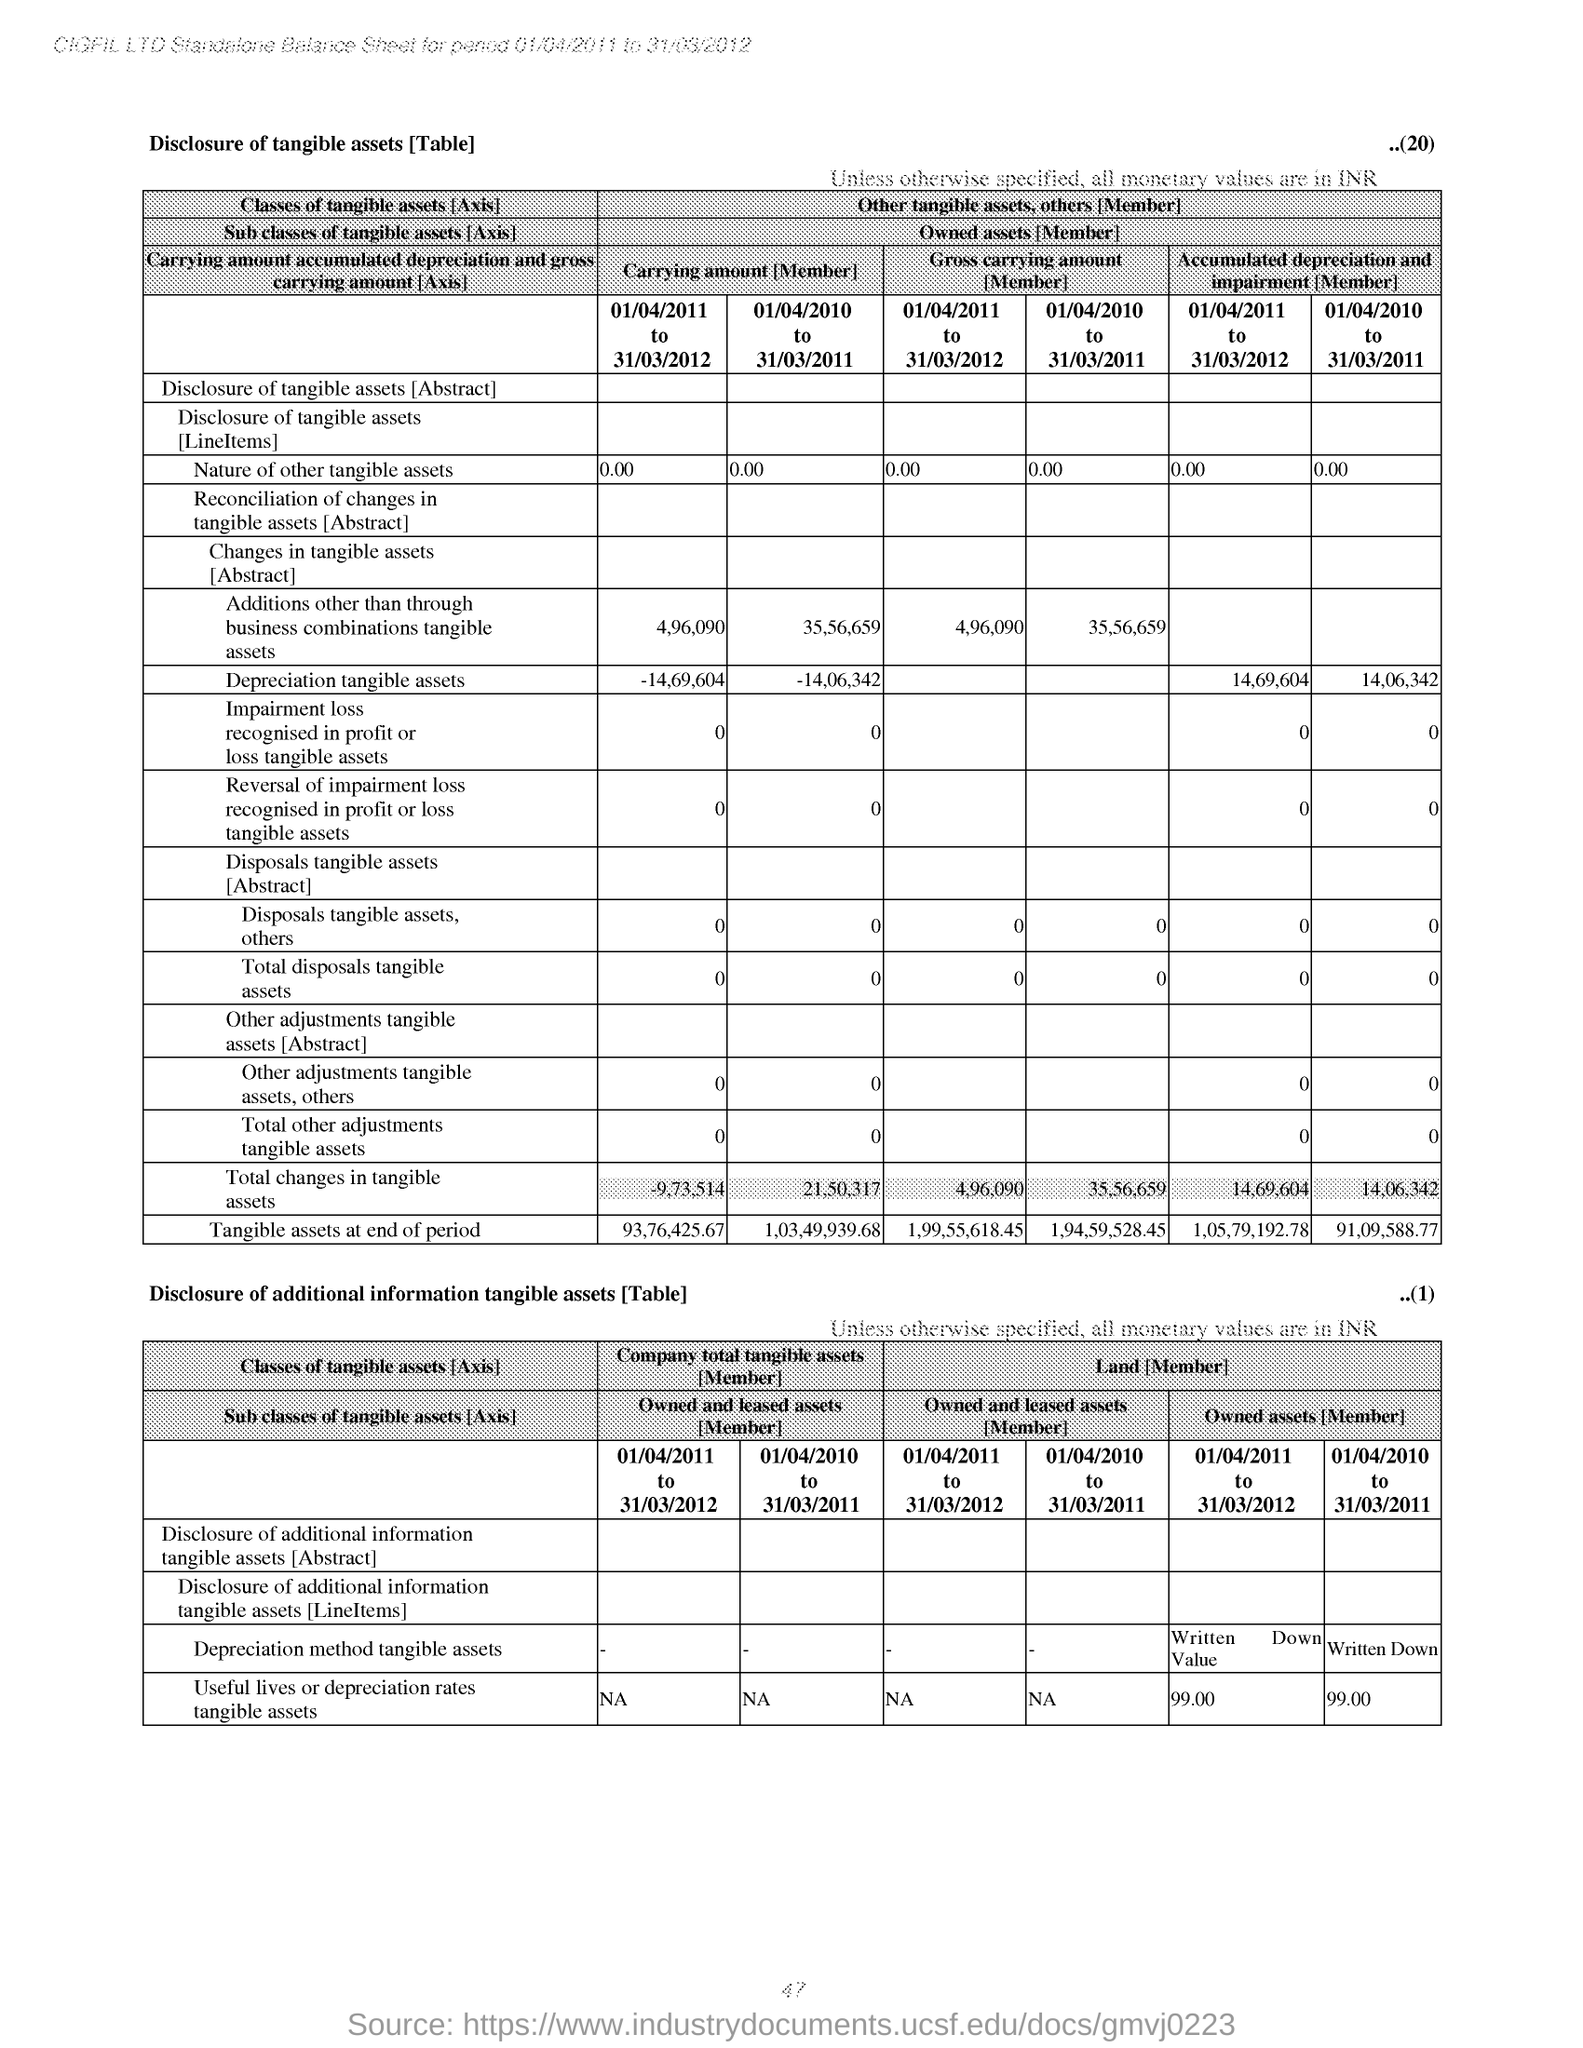Which period have less 'carrying amount' for 'Depreciation tangible assets' based on table 1?
Offer a terse response. 01/04/2010 to 31/03/2011. What is Accumulated depreciation and impairment for the period 01/04/2010 to 31/03/2011 for 'Depreciation tangible assets' based on table 1
Provide a succinct answer. 14,06,342. What is the Owned Assets for the period 01/04/2011 to 31/03/2012 for 'Useful lives or depreciation rates tangible assets' in table 2
Provide a short and direct response. 99.00. 